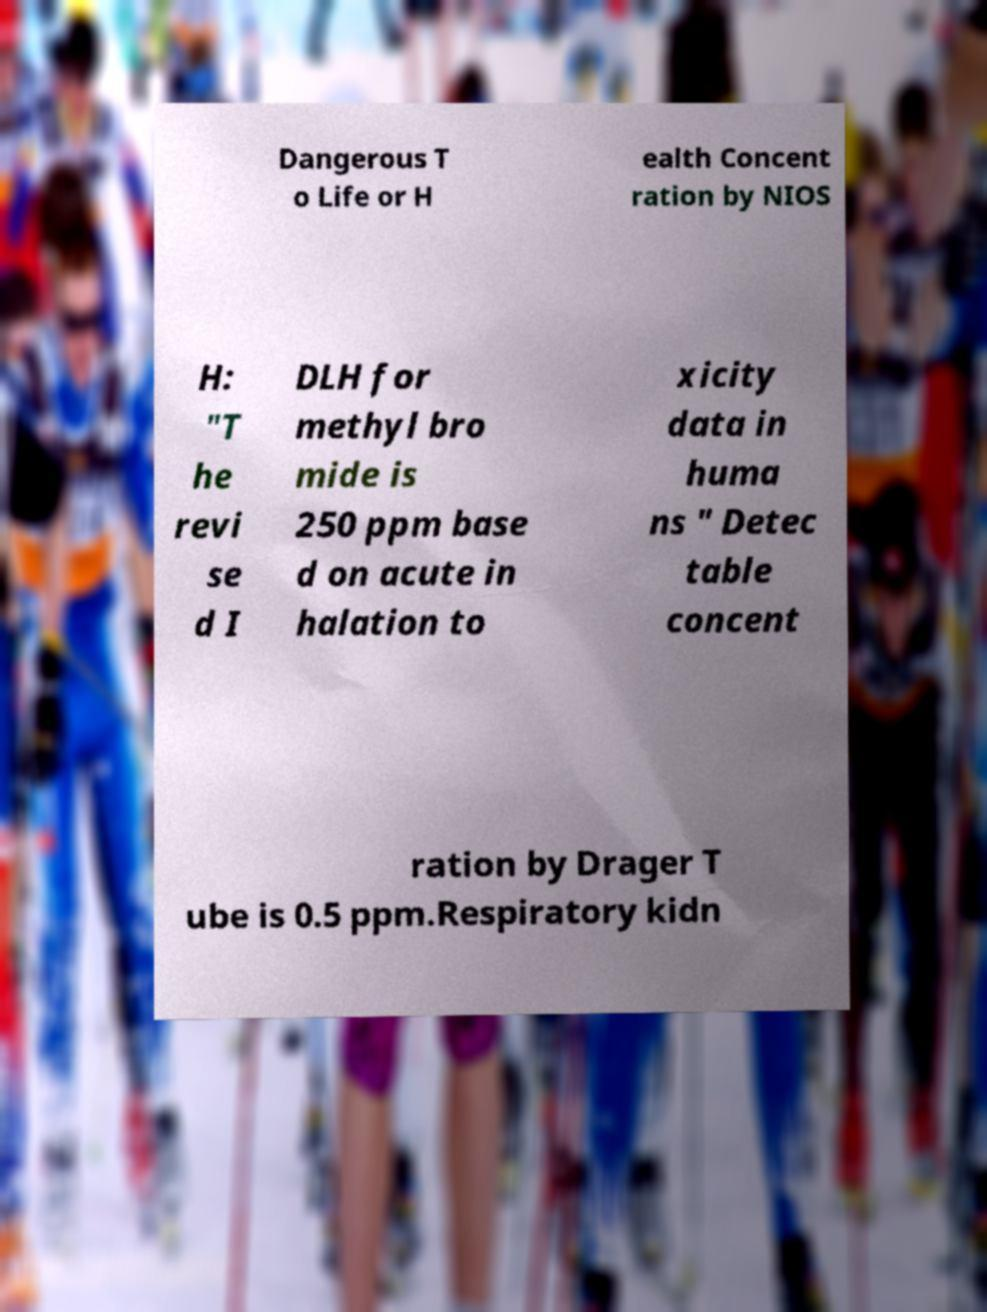Please read and relay the text visible in this image. What does it say? Dangerous T o Life or H ealth Concent ration by NIOS H: "T he revi se d I DLH for methyl bro mide is 250 ppm base d on acute in halation to xicity data in huma ns " Detec table concent ration by Drager T ube is 0.5 ppm.Respiratory kidn 